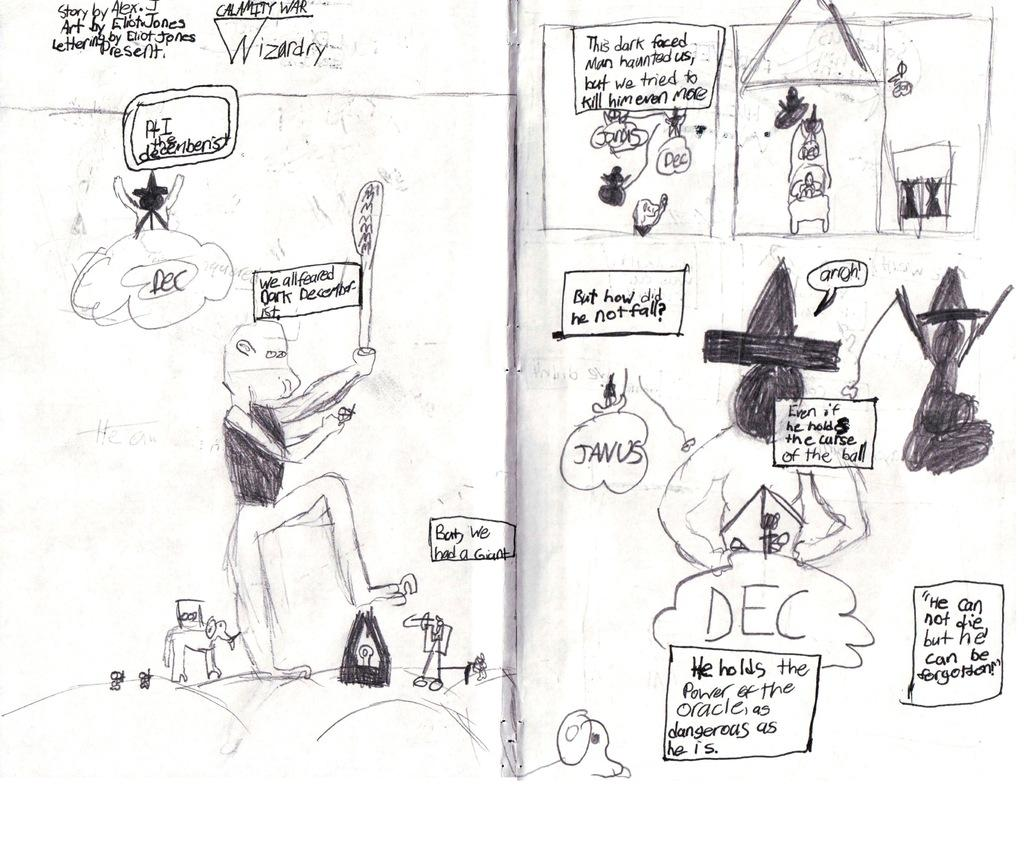What is depicted in the drawing in the image? There is a drawing of a person and a drawing of an animal in the image. What else is featured in the image besides the drawings? There is text in the image. How many brothers does the person in the drawing have? There is no information about the person's brothers in the image, as it only contains a drawing of a person and an animal, along with some text. What type of substance is being used to create the drawings in the image? There is no information about the substance used to create the drawings in the image. 